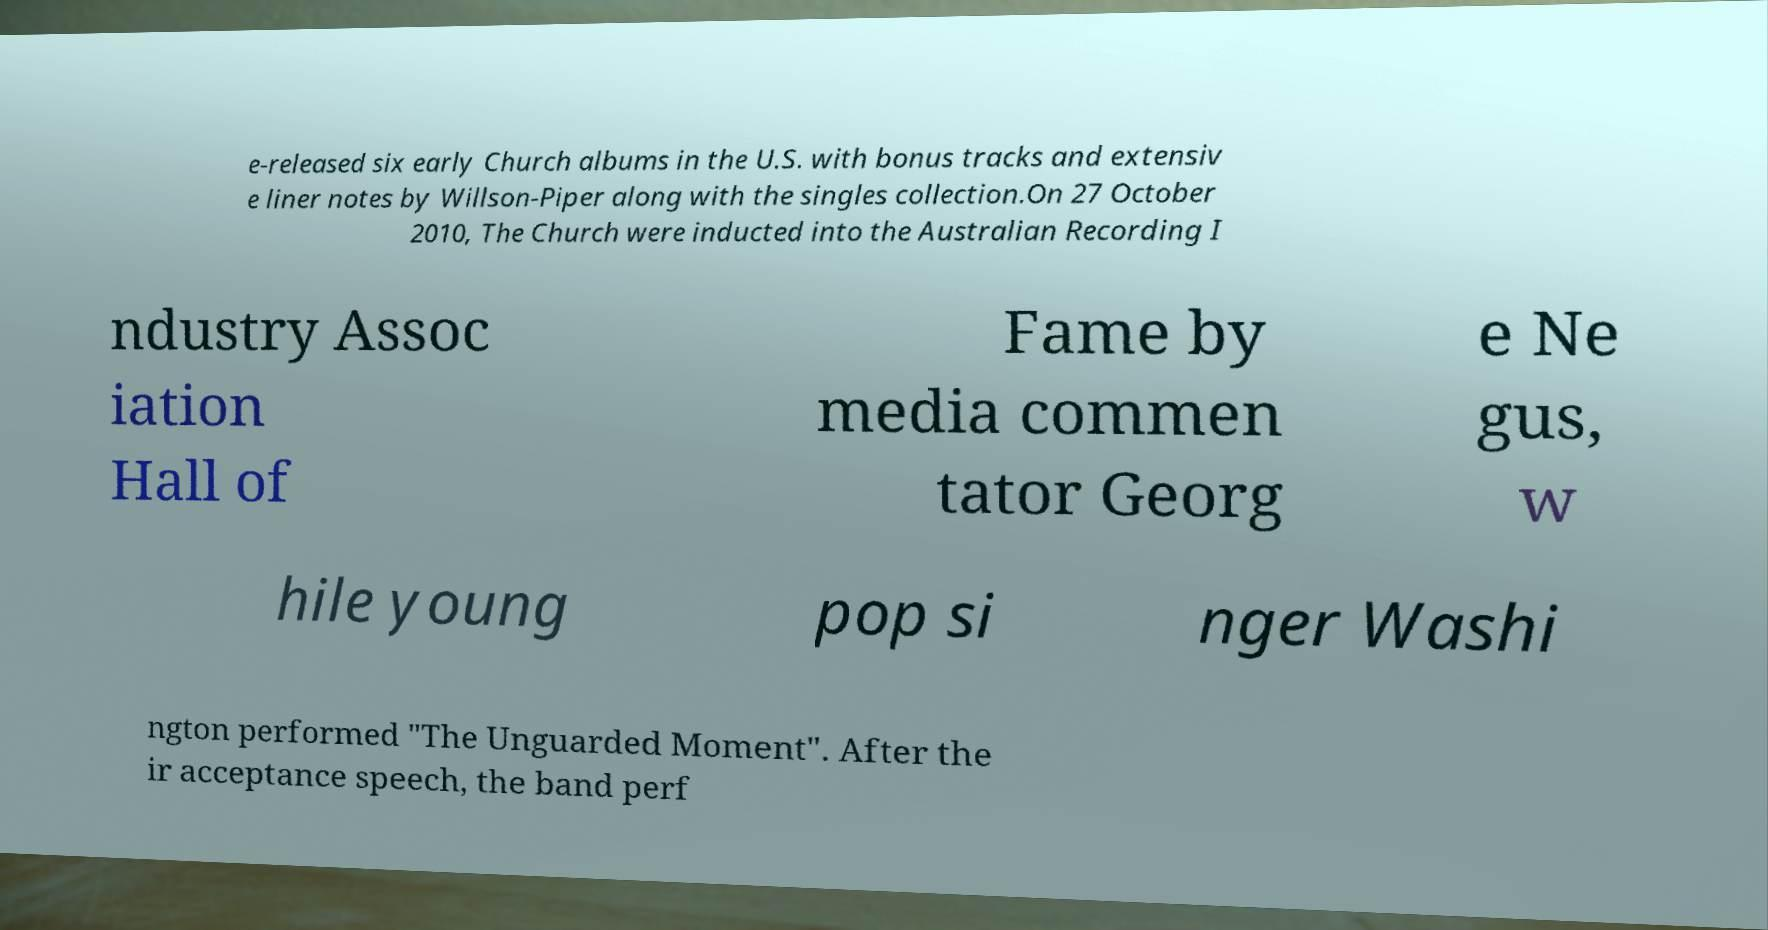There's text embedded in this image that I need extracted. Can you transcribe it verbatim? e-released six early Church albums in the U.S. with bonus tracks and extensiv e liner notes by Willson-Piper along with the singles collection.On 27 October 2010, The Church were inducted into the Australian Recording I ndustry Assoc iation Hall of Fame by media commen tator Georg e Ne gus, w hile young pop si nger Washi ngton performed "The Unguarded Moment". After the ir acceptance speech, the band perf 